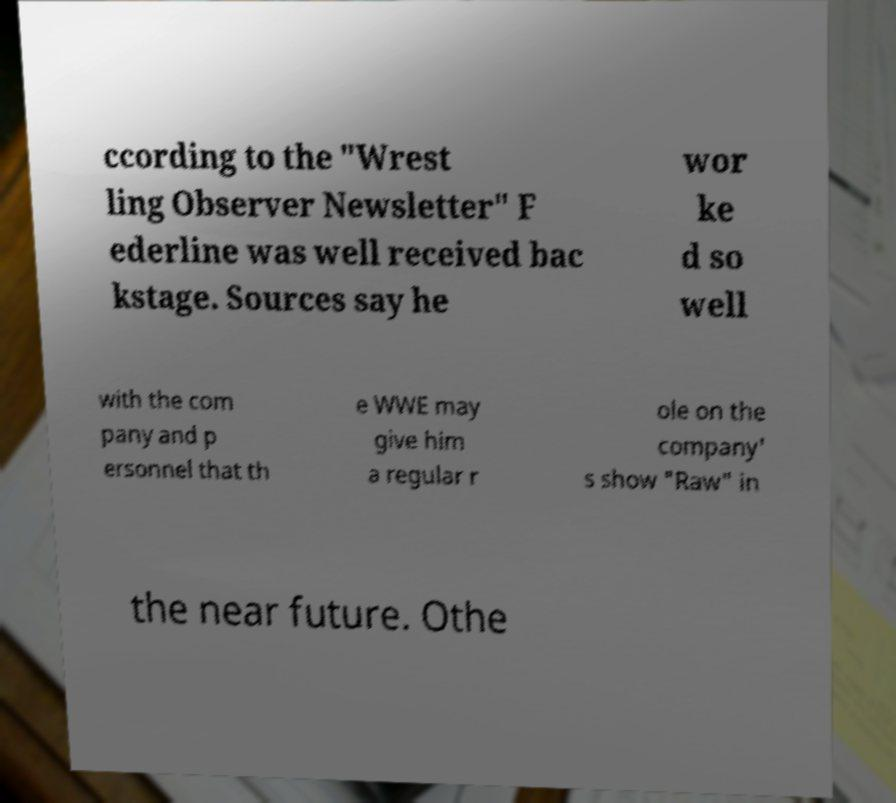What messages or text are displayed in this image? I need them in a readable, typed format. ccording to the "Wrest ling Observer Newsletter" F ederline was well received bac kstage. Sources say he wor ke d so well with the com pany and p ersonnel that th e WWE may give him a regular r ole on the company' s show "Raw" in the near future. Othe 